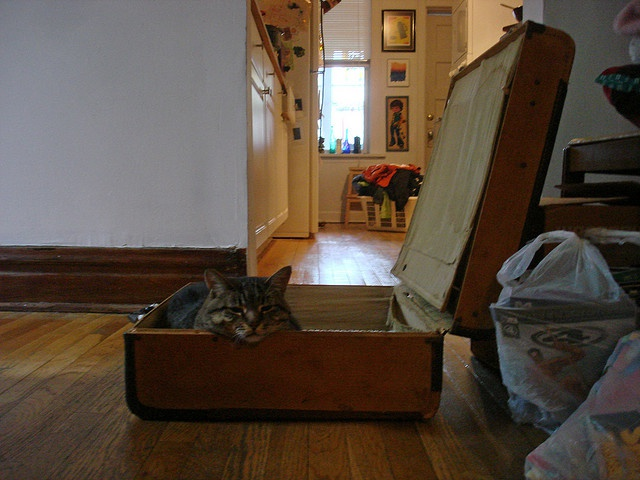Describe the objects in this image and their specific colors. I can see suitcase in gray, black, maroon, and olive tones, refrigerator in gray, olive, and maroon tones, cat in gray, black, maroon, and darkgreen tones, chair in gray, maroon, and brown tones, and vase in gray, lightblue, cyan, teal, and turquoise tones in this image. 